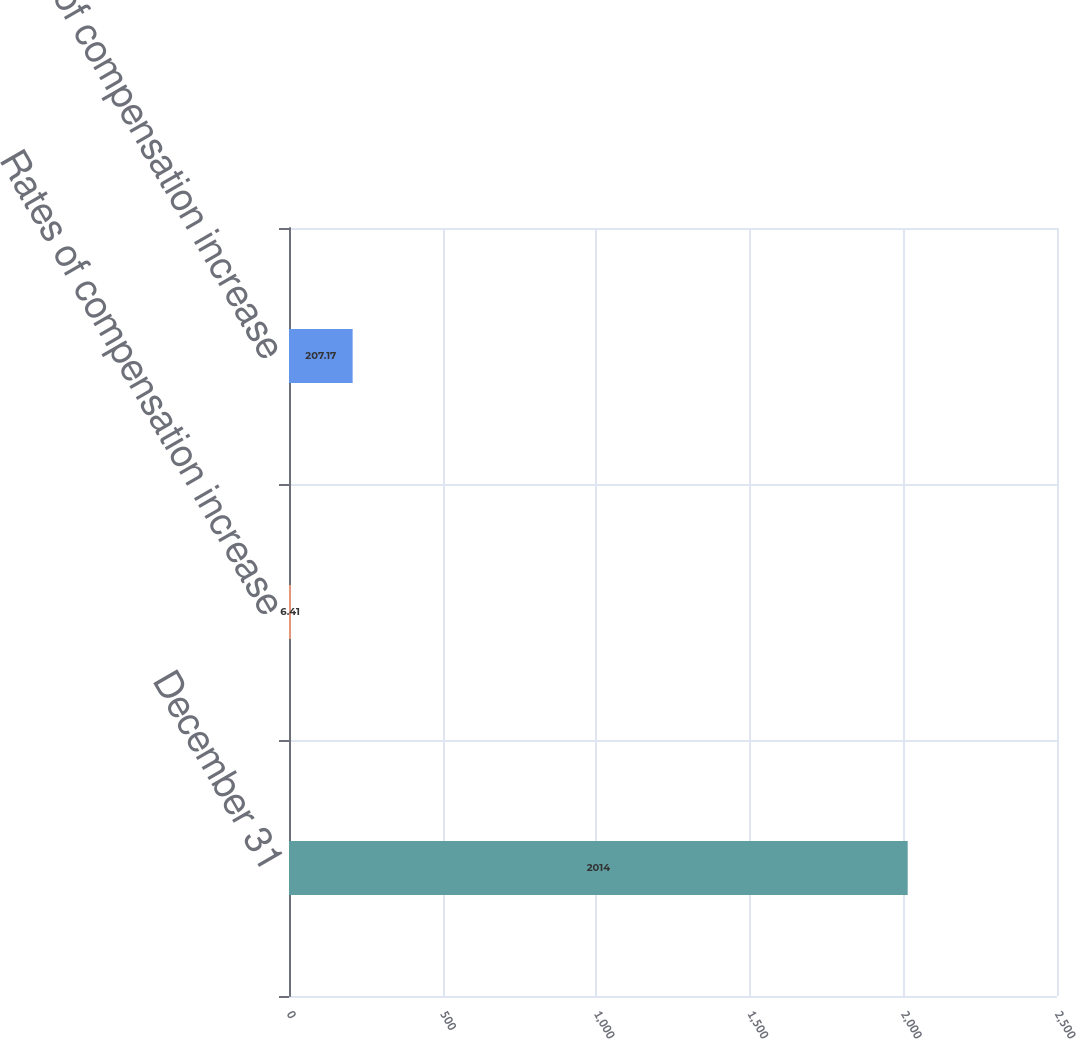Convert chart. <chart><loc_0><loc_0><loc_500><loc_500><bar_chart><fcel>December 31<fcel>Rates of compensation increase<fcel>Rate of compensation increase<nl><fcel>2014<fcel>6.41<fcel>207.17<nl></chart> 